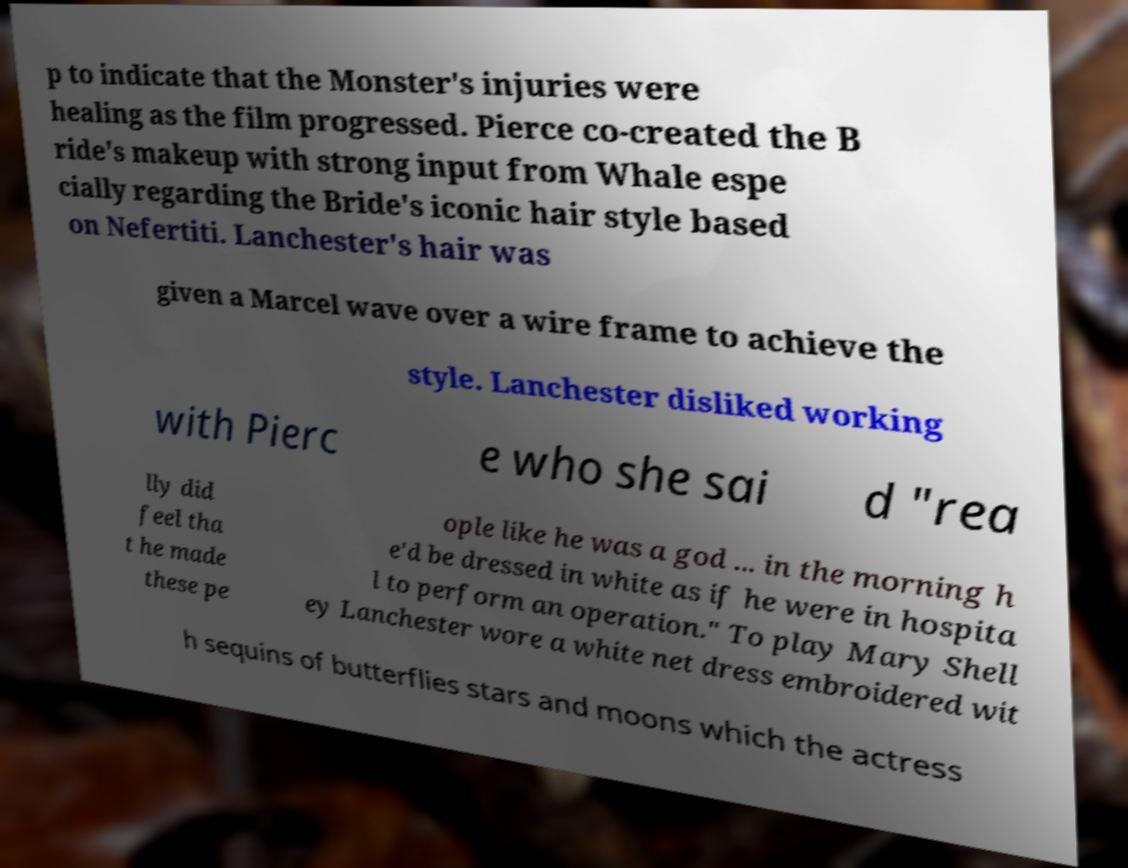For documentation purposes, I need the text within this image transcribed. Could you provide that? p to indicate that the Monster's injuries were healing as the film progressed. Pierce co-created the B ride's makeup with strong input from Whale espe cially regarding the Bride's iconic hair style based on Nefertiti. Lanchester's hair was given a Marcel wave over a wire frame to achieve the style. Lanchester disliked working with Pierc e who she sai d "rea lly did feel tha t he made these pe ople like he was a god ... in the morning h e'd be dressed in white as if he were in hospita l to perform an operation." To play Mary Shell ey Lanchester wore a white net dress embroidered wit h sequins of butterflies stars and moons which the actress 